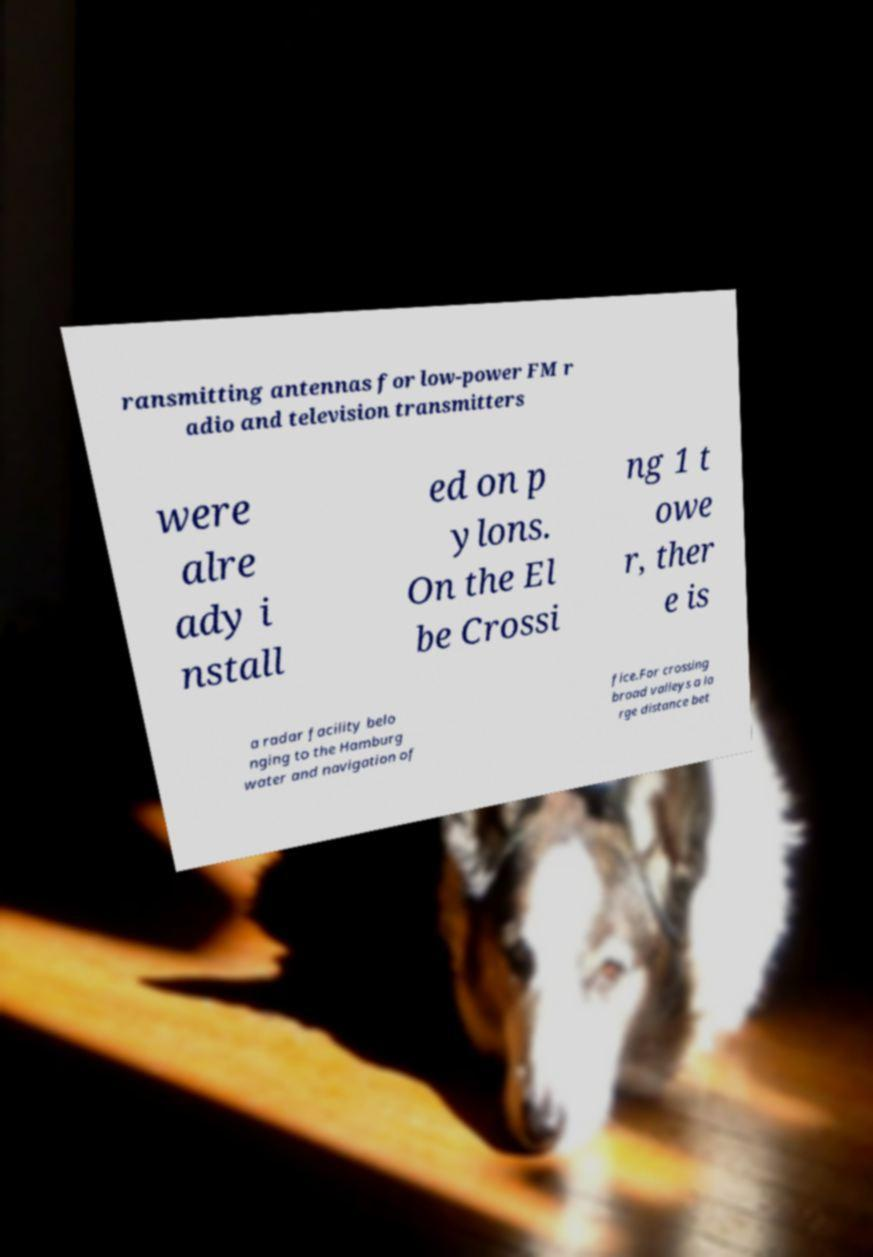I need the written content from this picture converted into text. Can you do that? ransmitting antennas for low-power FM r adio and television transmitters were alre ady i nstall ed on p ylons. On the El be Crossi ng 1 t owe r, ther e is a radar facility belo nging to the Hamburg water and navigation of fice.For crossing broad valleys a la rge distance bet 